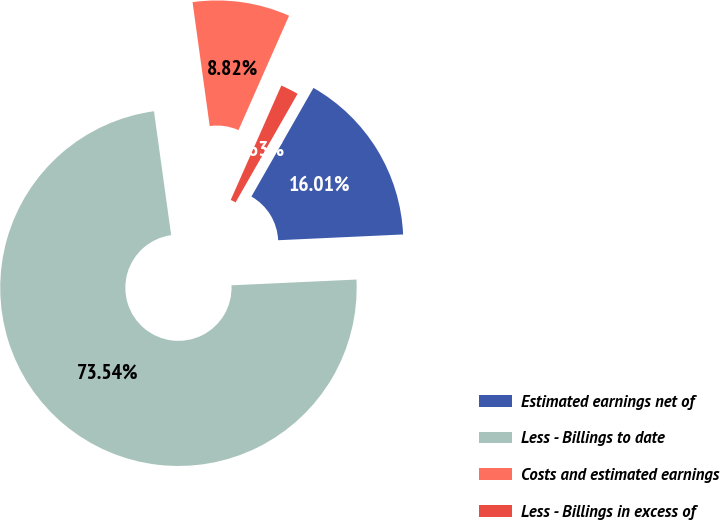Convert chart to OTSL. <chart><loc_0><loc_0><loc_500><loc_500><pie_chart><fcel>Estimated earnings net of<fcel>Less - Billings to date<fcel>Costs and estimated earnings<fcel>Less - Billings in excess of<nl><fcel>16.01%<fcel>73.54%<fcel>8.82%<fcel>1.63%<nl></chart> 